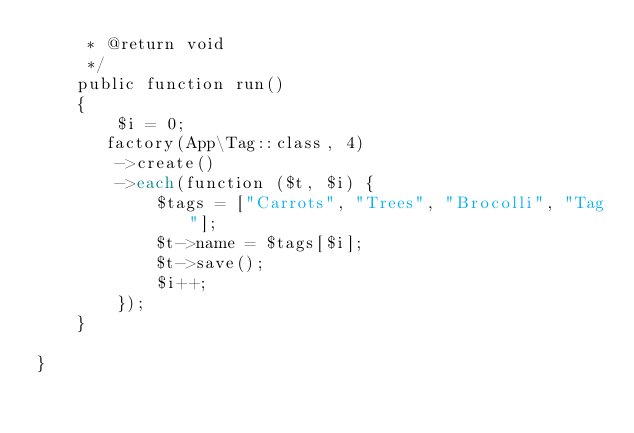Convert code to text. <code><loc_0><loc_0><loc_500><loc_500><_PHP_>     * @return void
     */
    public function run()
    {    
        $i = 0; 
       factory(App\Tag::class, 4)
        ->create()
        ->each(function ($t, $i) {
            $tags = ["Carrots", "Trees", "Brocolli", "Tag"];         
            $t->name = $tags[$i];
            $t->save();
            $i++;
        });
    }

}
</code> 